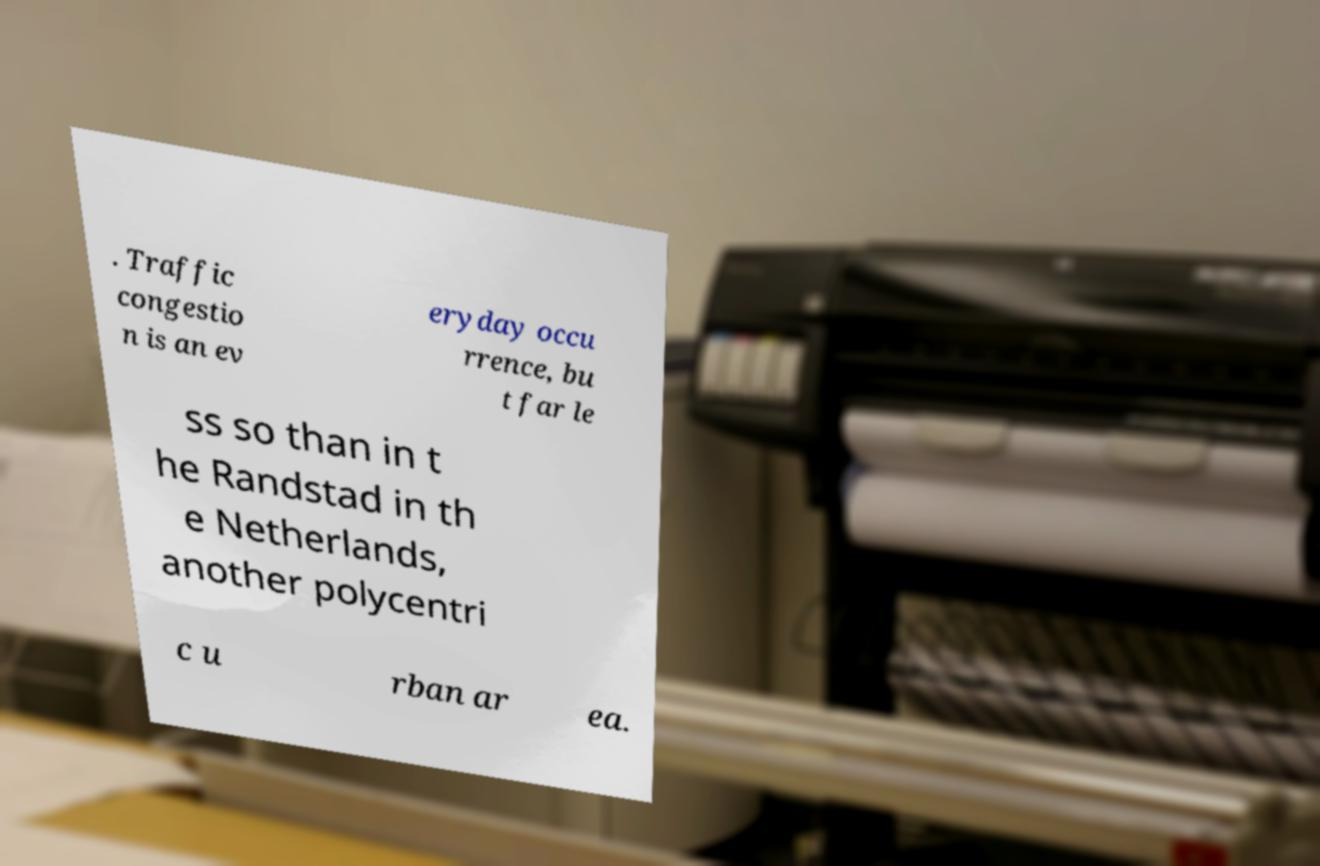Could you assist in decoding the text presented in this image and type it out clearly? . Traffic congestio n is an ev eryday occu rrence, bu t far le ss so than in t he Randstad in th e Netherlands, another polycentri c u rban ar ea. 